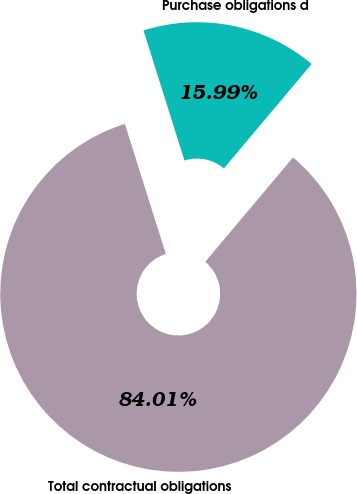Convert chart to OTSL. <chart><loc_0><loc_0><loc_500><loc_500><pie_chart><fcel>Purchase obligations d<fcel>Total contractual obligations<nl><fcel>15.99%<fcel>84.01%<nl></chart> 